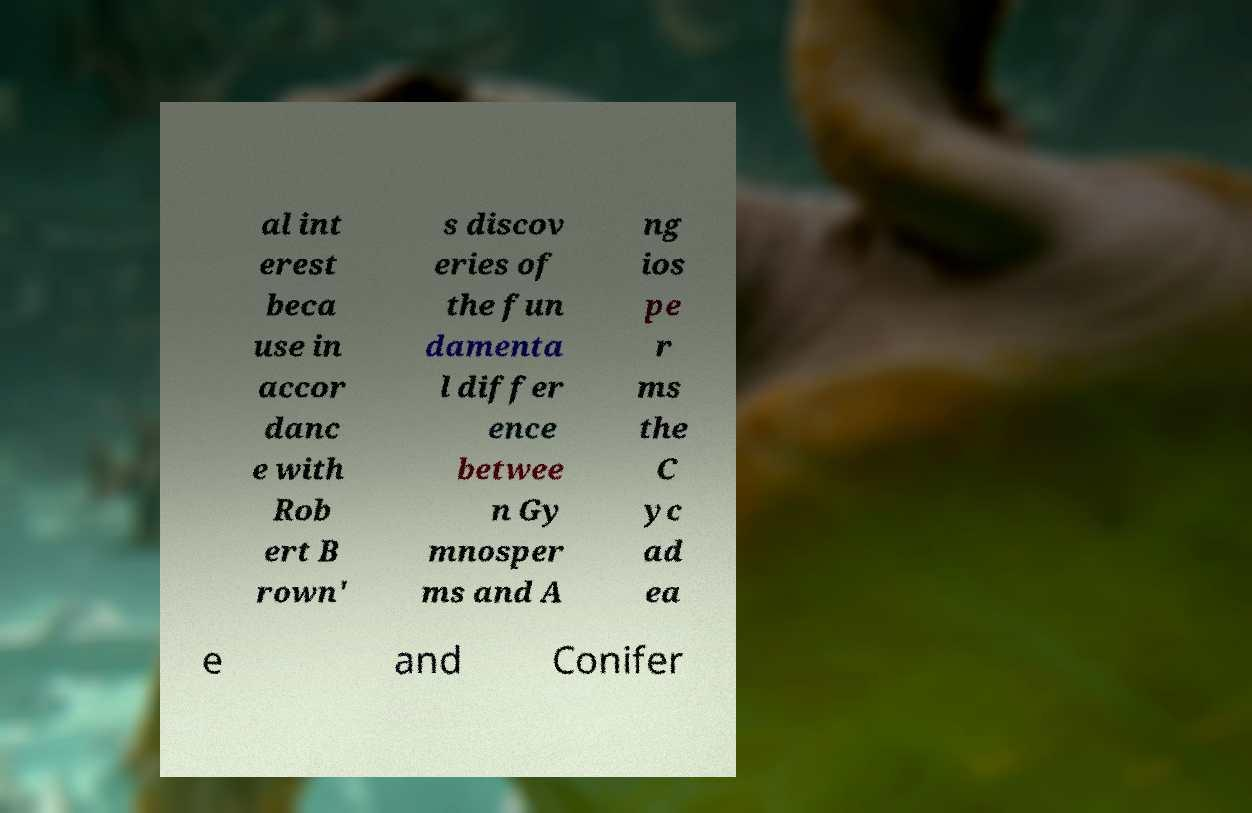For documentation purposes, I need the text within this image transcribed. Could you provide that? al int erest beca use in accor danc e with Rob ert B rown' s discov eries of the fun damenta l differ ence betwee n Gy mnosper ms and A ng ios pe r ms the C yc ad ea e and Conifer 